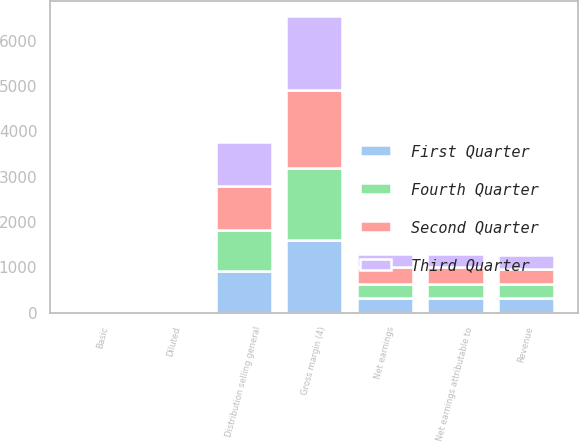Convert chart to OTSL. <chart><loc_0><loc_0><loc_500><loc_500><stacked_bar_chart><ecel><fcel>Revenue<fcel>Gross margin (4)<fcel>Distribution selling general<fcel>Net earnings<fcel>Net earnings attributable to<fcel>Basic<fcel>Diluted<nl><fcel>Fourth Quarter<fcel>317<fcel>1590<fcel>920<fcel>310<fcel>309<fcel>0.97<fcel>0.96<nl><fcel>First Quarter<fcel>317<fcel>1602<fcel>910<fcel>324<fcel>324<fcel>1.02<fcel>1.02<nl><fcel>Second Quarter<fcel>317<fcel>1728<fcel>960<fcel>382<fcel>381<fcel>1.21<fcel>1.2<nl><fcel>Third Quarter<fcel>317<fcel>1623<fcel>983<fcel>278<fcel>274<fcel>0.87<fcel>0.86<nl></chart> 